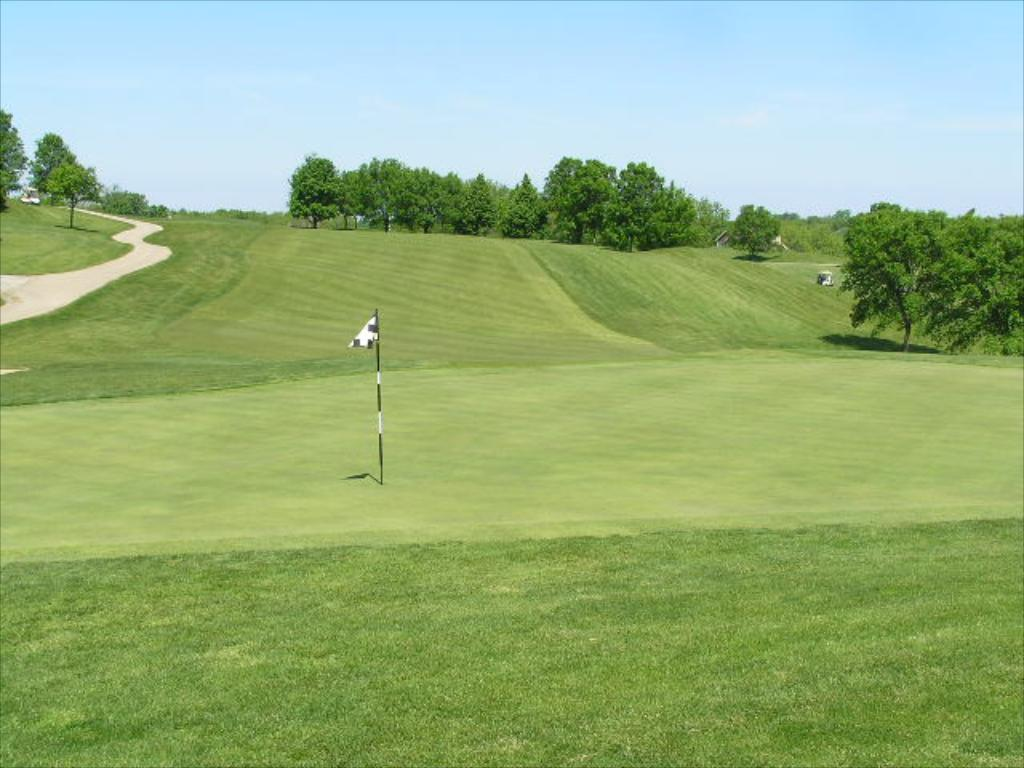What type of surface is visible in the image? There is a grass lawn in the image. What is located on the grass lawn? There is a flag with a pole on the grass lawn. What can be seen on the left side of the image? There is a road on the left side of the image. What type of vegetation is visible in the image? There are trees visible in the image. What is visible above the grass lawn and trees? The sky is visible in the image. What type of lead can be seen being used by the trees in the image? There is no lead present in the image, and the trees are not using any lead. 